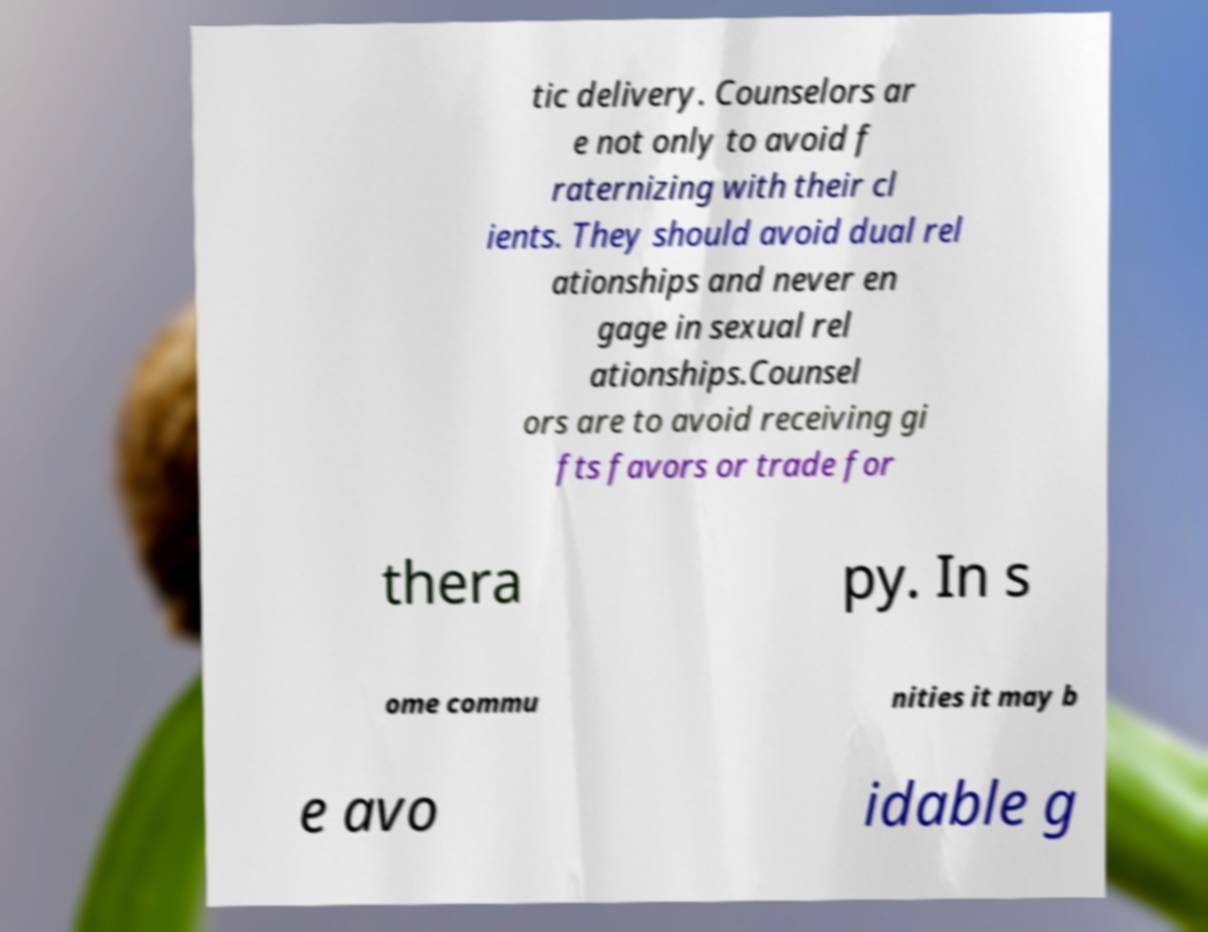Could you extract and type out the text from this image? tic delivery. Counselors ar e not only to avoid f raternizing with their cl ients. They should avoid dual rel ationships and never en gage in sexual rel ationships.Counsel ors are to avoid receiving gi fts favors or trade for thera py. In s ome commu nities it may b e avo idable g 